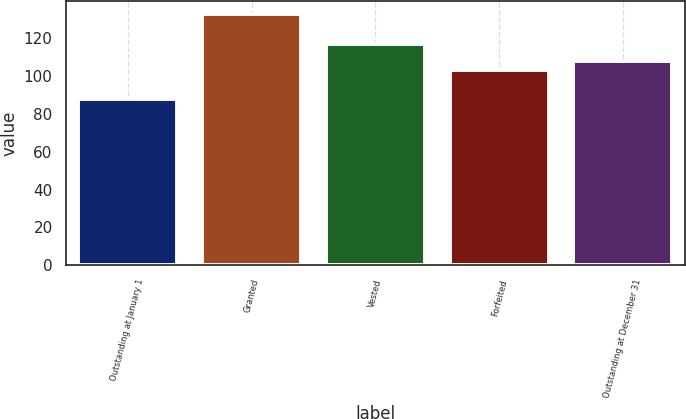Convert chart. <chart><loc_0><loc_0><loc_500><loc_500><bar_chart><fcel>Outstanding at January 1<fcel>Granted<fcel>Vested<fcel>Forfeited<fcel>Outstanding at December 31<nl><fcel>87.86<fcel>132.95<fcel>116.83<fcel>103.29<fcel>107.8<nl></chart> 